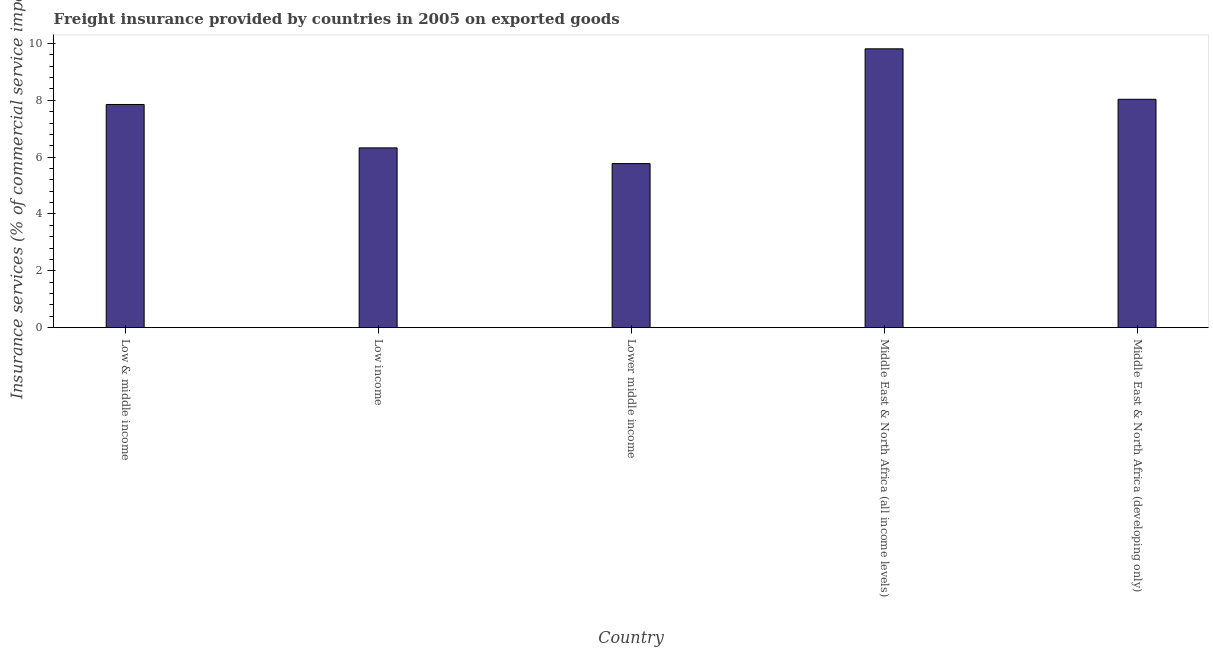Does the graph contain any zero values?
Ensure brevity in your answer.  No. What is the title of the graph?
Make the answer very short. Freight insurance provided by countries in 2005 on exported goods . What is the label or title of the X-axis?
Your response must be concise. Country. What is the label or title of the Y-axis?
Give a very brief answer. Insurance services (% of commercial service imports). What is the freight insurance in Middle East & North Africa (all income levels)?
Ensure brevity in your answer.  9.81. Across all countries, what is the maximum freight insurance?
Ensure brevity in your answer.  9.81. Across all countries, what is the minimum freight insurance?
Your answer should be compact. 5.77. In which country was the freight insurance maximum?
Provide a succinct answer. Middle East & North Africa (all income levels). In which country was the freight insurance minimum?
Your response must be concise. Lower middle income. What is the sum of the freight insurance?
Make the answer very short. 37.8. What is the difference between the freight insurance in Middle East & North Africa (all income levels) and Middle East & North Africa (developing only)?
Your answer should be compact. 1.78. What is the average freight insurance per country?
Offer a terse response. 7.56. What is the median freight insurance?
Provide a short and direct response. 7.85. In how many countries, is the freight insurance greater than 7.6 %?
Your answer should be compact. 3. What is the ratio of the freight insurance in Middle East & North Africa (all income levels) to that in Middle East & North Africa (developing only)?
Give a very brief answer. 1.22. Is the freight insurance in Low & middle income less than that in Middle East & North Africa (all income levels)?
Provide a succinct answer. Yes. Is the difference between the freight insurance in Low & middle income and Lower middle income greater than the difference between any two countries?
Make the answer very short. No. What is the difference between the highest and the second highest freight insurance?
Your answer should be compact. 1.78. Is the sum of the freight insurance in Low income and Middle East & North Africa (all income levels) greater than the maximum freight insurance across all countries?
Provide a short and direct response. Yes. What is the difference between the highest and the lowest freight insurance?
Give a very brief answer. 4.04. How many bars are there?
Provide a succinct answer. 5. How many countries are there in the graph?
Offer a terse response. 5. What is the Insurance services (% of commercial service imports) of Low & middle income?
Offer a terse response. 7.85. What is the Insurance services (% of commercial service imports) in Low income?
Your response must be concise. 6.33. What is the Insurance services (% of commercial service imports) in Lower middle income?
Your answer should be very brief. 5.77. What is the Insurance services (% of commercial service imports) in Middle East & North Africa (all income levels)?
Offer a terse response. 9.81. What is the Insurance services (% of commercial service imports) in Middle East & North Africa (developing only)?
Offer a terse response. 8.04. What is the difference between the Insurance services (% of commercial service imports) in Low & middle income and Low income?
Provide a short and direct response. 1.53. What is the difference between the Insurance services (% of commercial service imports) in Low & middle income and Lower middle income?
Ensure brevity in your answer.  2.08. What is the difference between the Insurance services (% of commercial service imports) in Low & middle income and Middle East & North Africa (all income levels)?
Provide a succinct answer. -1.96. What is the difference between the Insurance services (% of commercial service imports) in Low & middle income and Middle East & North Africa (developing only)?
Your answer should be compact. -0.18. What is the difference between the Insurance services (% of commercial service imports) in Low income and Lower middle income?
Ensure brevity in your answer.  0.55. What is the difference between the Insurance services (% of commercial service imports) in Low income and Middle East & North Africa (all income levels)?
Ensure brevity in your answer.  -3.49. What is the difference between the Insurance services (% of commercial service imports) in Low income and Middle East & North Africa (developing only)?
Make the answer very short. -1.71. What is the difference between the Insurance services (% of commercial service imports) in Lower middle income and Middle East & North Africa (all income levels)?
Provide a succinct answer. -4.04. What is the difference between the Insurance services (% of commercial service imports) in Lower middle income and Middle East & North Africa (developing only)?
Your answer should be compact. -2.26. What is the difference between the Insurance services (% of commercial service imports) in Middle East & North Africa (all income levels) and Middle East & North Africa (developing only)?
Your response must be concise. 1.78. What is the ratio of the Insurance services (% of commercial service imports) in Low & middle income to that in Low income?
Make the answer very short. 1.24. What is the ratio of the Insurance services (% of commercial service imports) in Low & middle income to that in Lower middle income?
Ensure brevity in your answer.  1.36. What is the ratio of the Insurance services (% of commercial service imports) in Low & middle income to that in Middle East & North Africa (all income levels)?
Offer a very short reply. 0.8. What is the ratio of the Insurance services (% of commercial service imports) in Low income to that in Lower middle income?
Provide a succinct answer. 1.1. What is the ratio of the Insurance services (% of commercial service imports) in Low income to that in Middle East & North Africa (all income levels)?
Keep it short and to the point. 0.65. What is the ratio of the Insurance services (% of commercial service imports) in Low income to that in Middle East & North Africa (developing only)?
Your answer should be compact. 0.79. What is the ratio of the Insurance services (% of commercial service imports) in Lower middle income to that in Middle East & North Africa (all income levels)?
Make the answer very short. 0.59. What is the ratio of the Insurance services (% of commercial service imports) in Lower middle income to that in Middle East & North Africa (developing only)?
Give a very brief answer. 0.72. What is the ratio of the Insurance services (% of commercial service imports) in Middle East & North Africa (all income levels) to that in Middle East & North Africa (developing only)?
Your answer should be very brief. 1.22. 